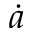<formula> <loc_0><loc_0><loc_500><loc_500>\dot { a }</formula> 